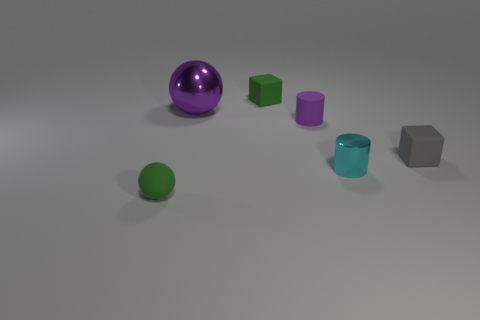Add 4 small red metallic cubes. How many objects exist? 10 Add 6 small purple cylinders. How many small purple cylinders exist? 7 Subtract 1 cyan cylinders. How many objects are left? 5 Subtract all big metal balls. Subtract all cyan cylinders. How many objects are left? 4 Add 1 tiny cylinders. How many tiny cylinders are left? 3 